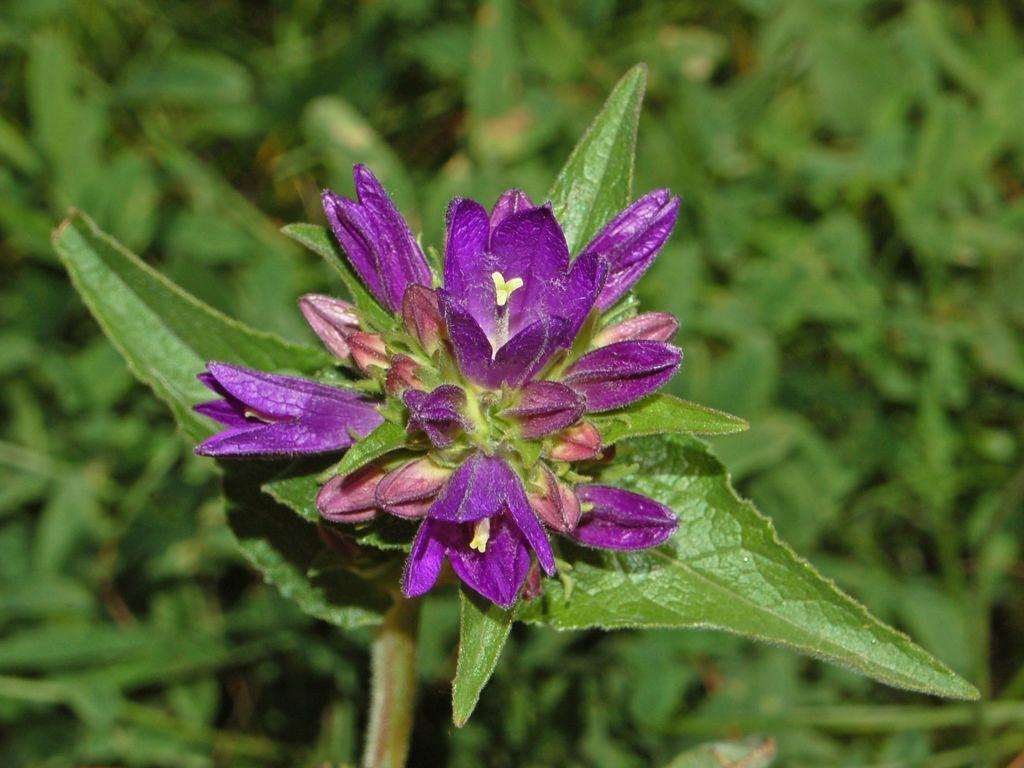What is located in the middle of the image? There are small flowers in the middle of the image. What can be seen in the background of the image? There are many plants in the background of the image. What type of mint is being used to transport the scarecrow in the image? There is no scarecrow or mint present in the image, and therefore no such activity can be observed. 